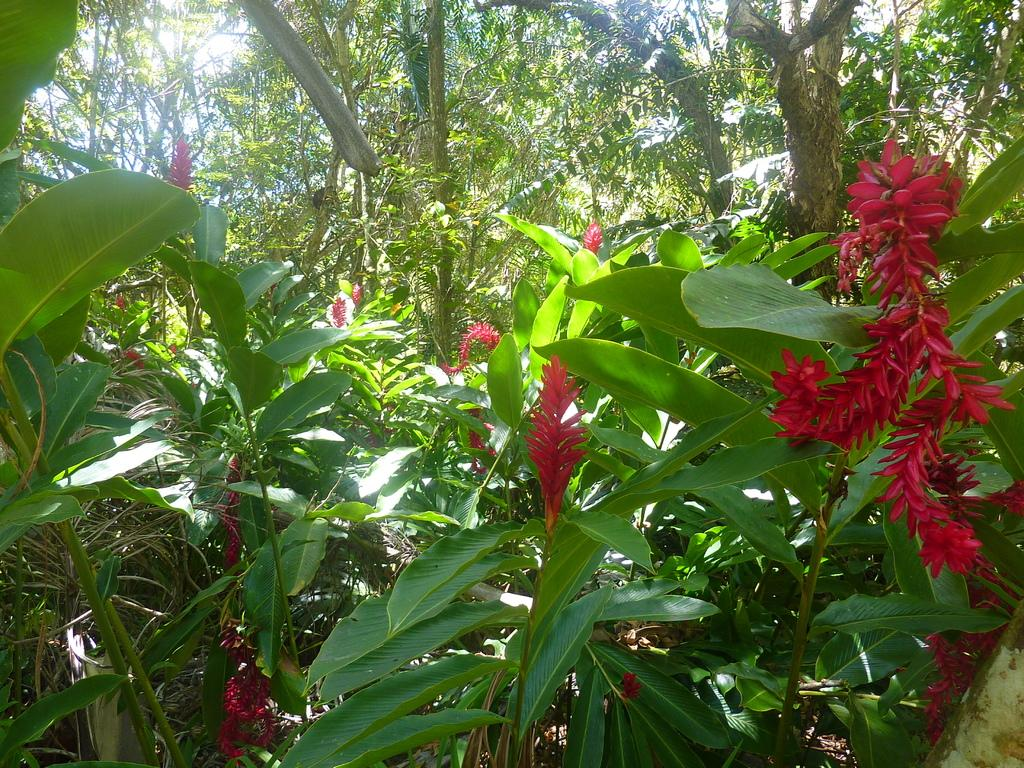What type of vegetation can be seen in the image? There are trees and plants in the image. Can you describe the specific types of trees and plants? Unfortunately, the provided facts do not specify the types of trees and plants in the image. What is the setting or environment of the image? The presence of trees and plants suggests that the image is set in a natural or outdoor environment. What type of structure can be seen balancing on a single line in the image? There is no structure or line present in the image; it only features trees and plants. 